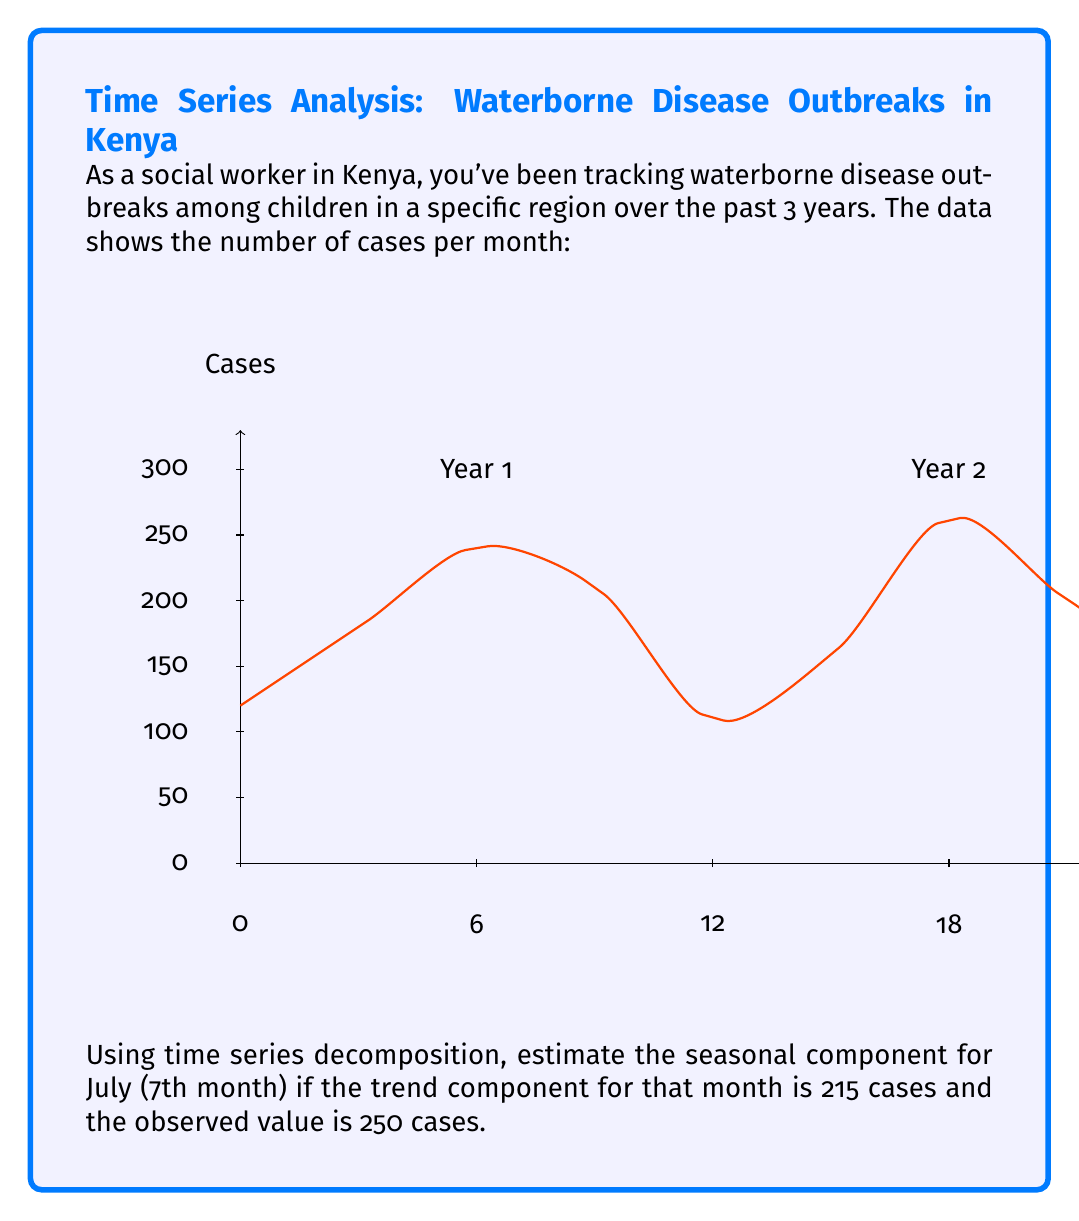Provide a solution to this math problem. To solve this problem, we'll use the additive time series decomposition model:

$$Y_t = T_t + S_t + R_t$$

Where:
$Y_t$ = Observed value
$T_t$ = Trend component
$S_t$ = Seasonal component
$R_t$ = Residual component

We're given:
$Y_t$ (Observed value for July) = 250 cases
$T_t$ (Trend component for July) = 215 cases

Step 1: Rearrange the equation to solve for the seasonal component:
$$S_t = Y_t - T_t - R_t$$

Step 2: Since we're asked to estimate the seasonal component, we'll assume the residual component ($R_t$) is negligible (close to zero). This gives us:
$$S_t \approx Y_t - T_t$$

Step 3: Plug in the known values:
$$S_t \approx 250 - 215$$

Step 4: Calculate the seasonal component:
$$S_t \approx 35$$

Therefore, the estimated seasonal component for July is approximately 35 cases.
Answer: 35 cases 